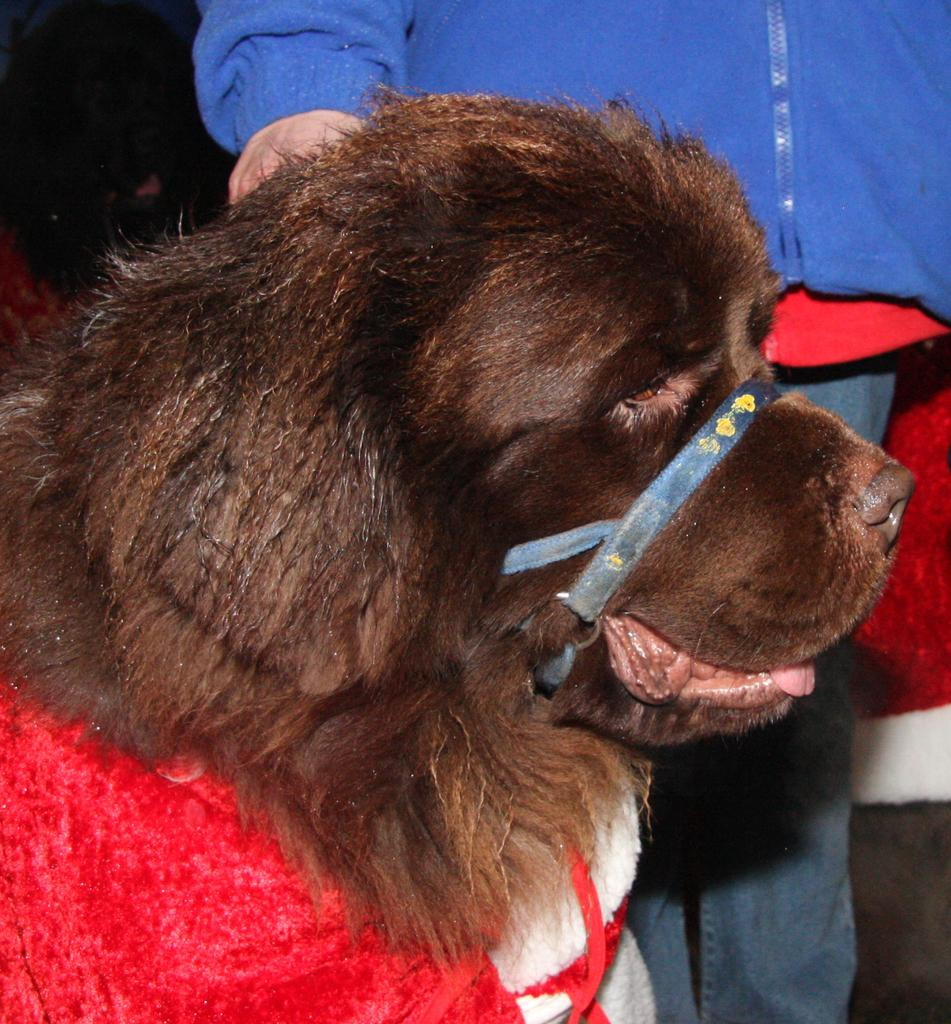What type of animal is in the image? There is a dog in the image. Who or what else is present in the image? There is a person standing in the image. What can be observed about the background of the image? The background of the image is dark. What type of locket is the dog wearing in the image? There is no locket present in the image, as the dog is not wearing any accessories. Can you see any toy in the image? There is no toy visible in the image; it only features a dog and a person. 